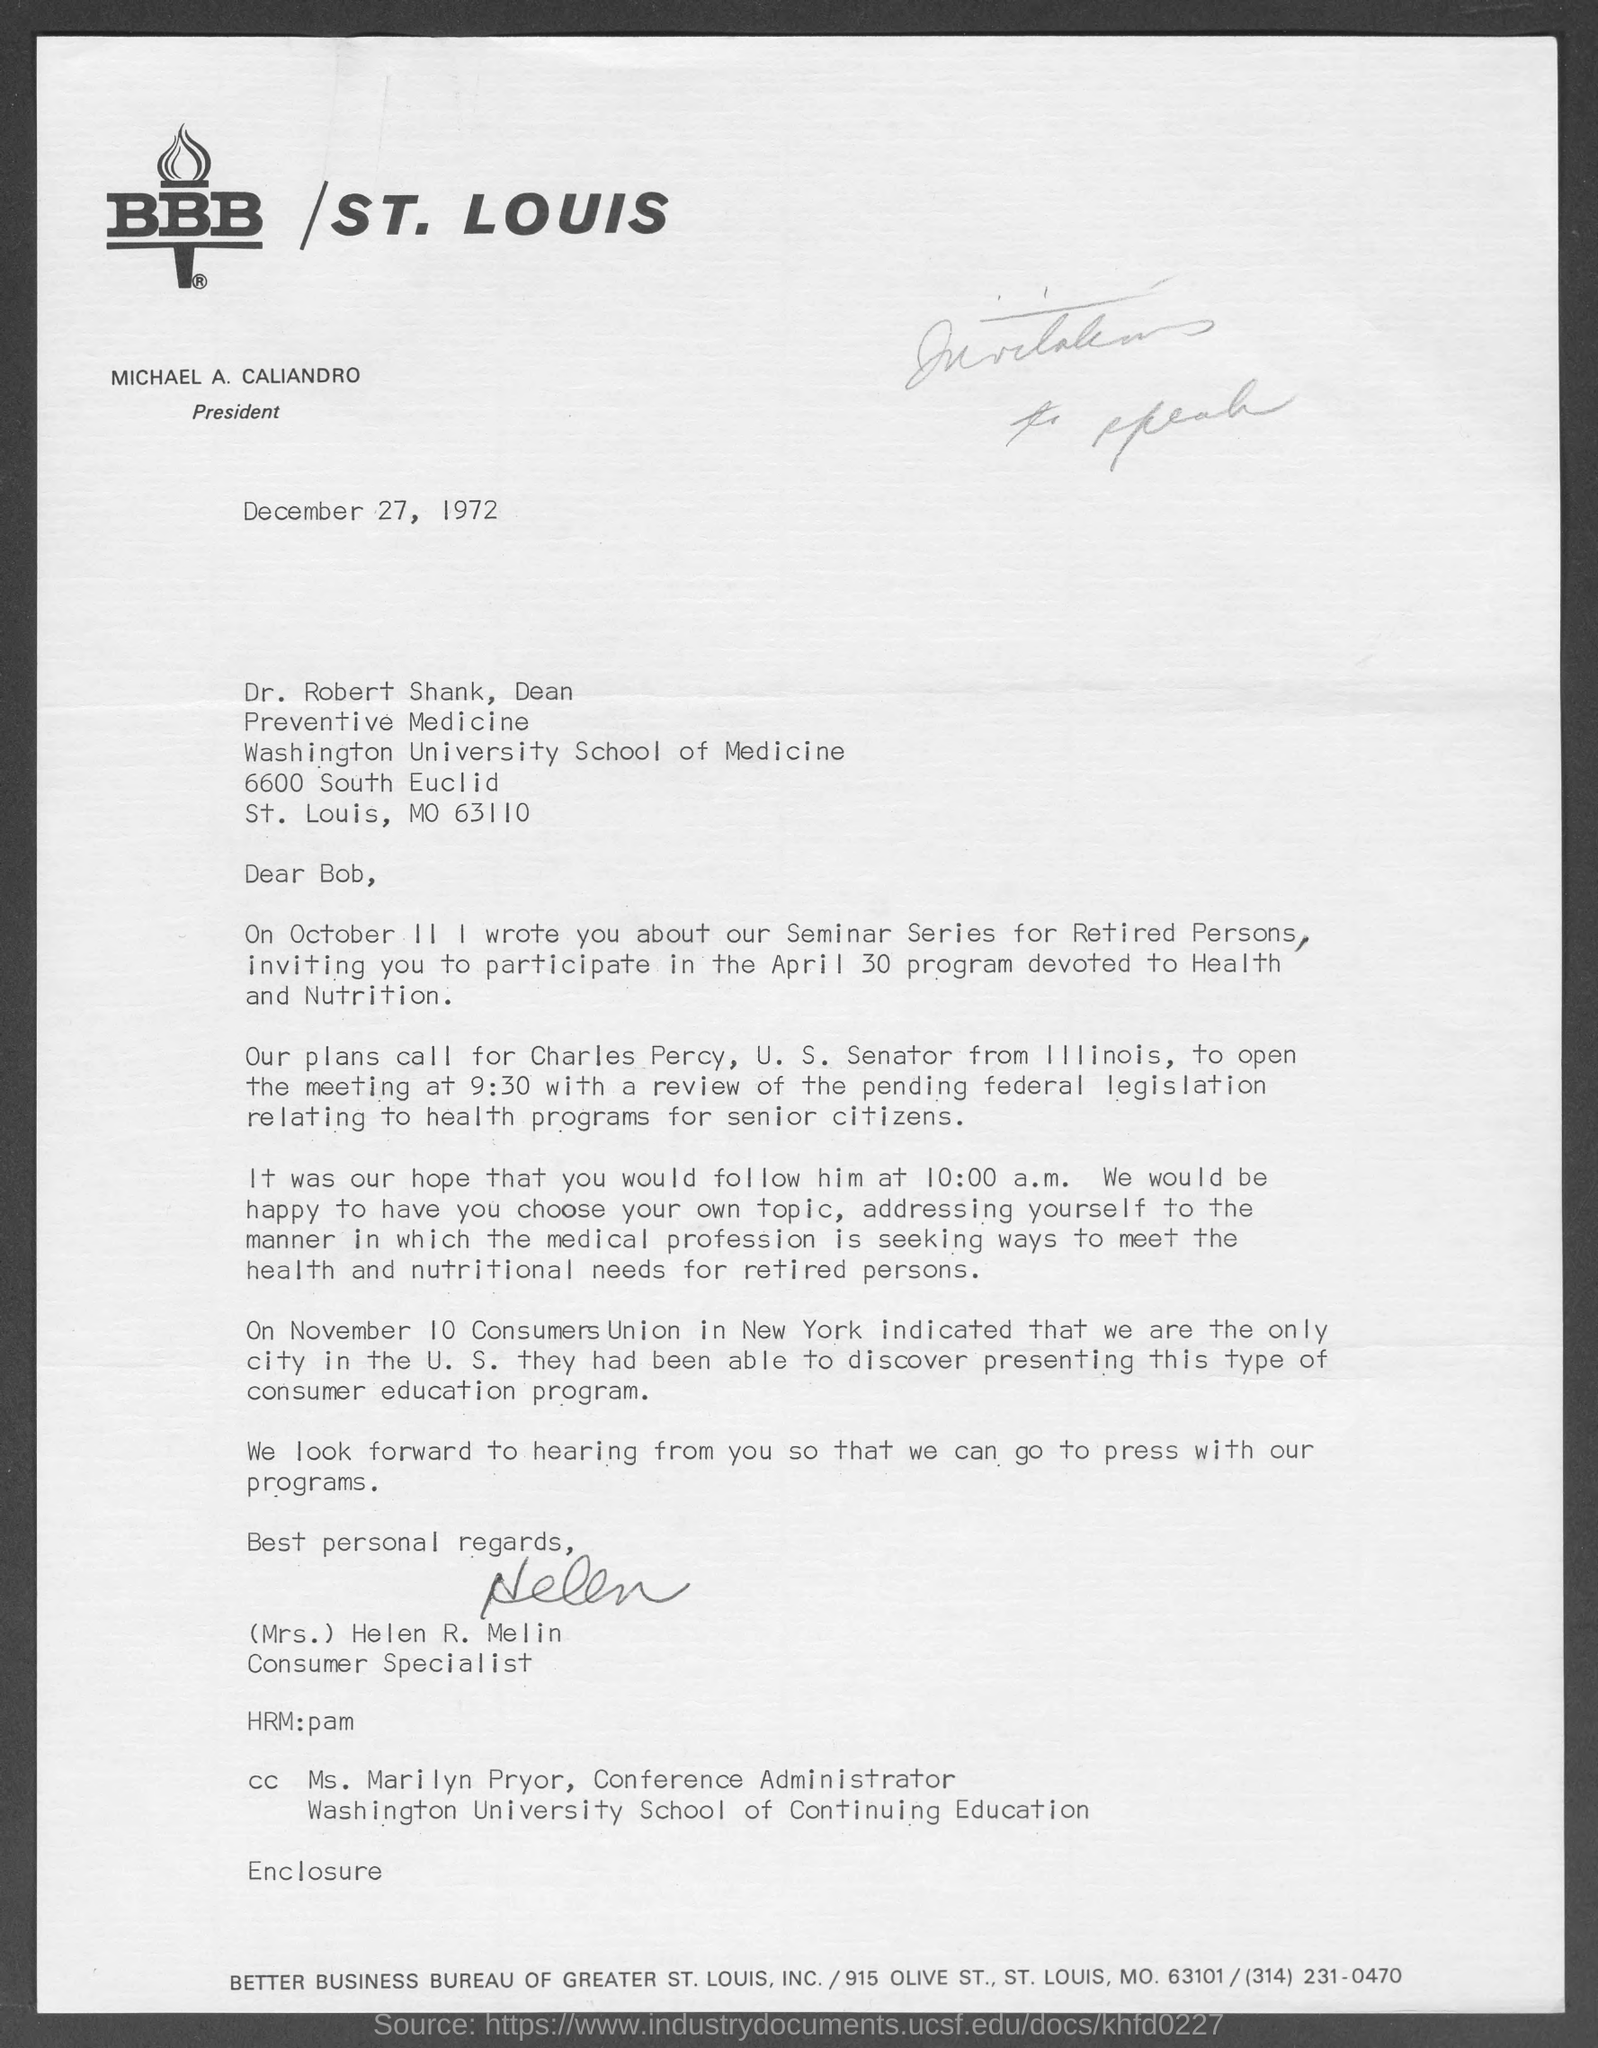Who is the president of st.louis?
Make the answer very short. Michael A. caliandro. Who is the dean of preventive medicine?
Ensure brevity in your answer.  Dr. Robert shank. Who is the consumer specialist?
Your response must be concise. (mrs.) helen r. melin. Who is the conference administrator, washington university school of continuing studies?
Ensure brevity in your answer.  Ms. Marilyn Pryor. What is the name of u.s senator from illinois?
Ensure brevity in your answer.  Charles Percy. What is the date letter is written on?
Your answer should be compact. December 27, 1972. What is mo of st. louis?
Provide a short and direct response. 63110. 